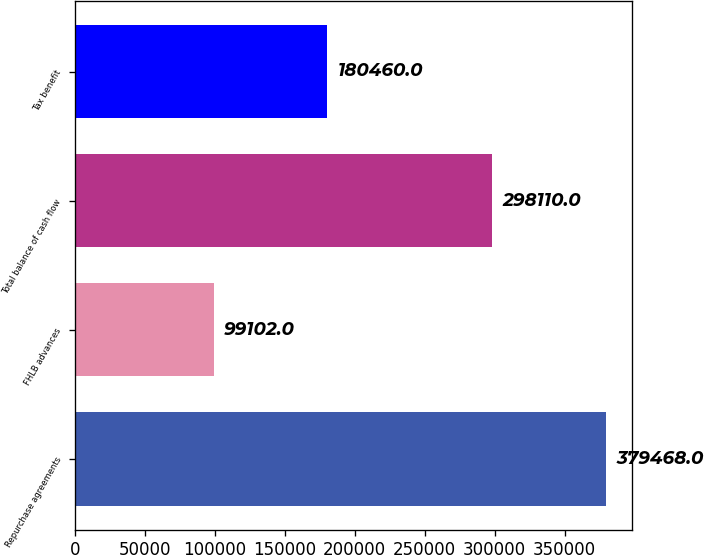<chart> <loc_0><loc_0><loc_500><loc_500><bar_chart><fcel>Repurchase agreements<fcel>FHLB advances<fcel>Total balance of cash flow<fcel>Tax benefit<nl><fcel>379468<fcel>99102<fcel>298110<fcel>180460<nl></chart> 